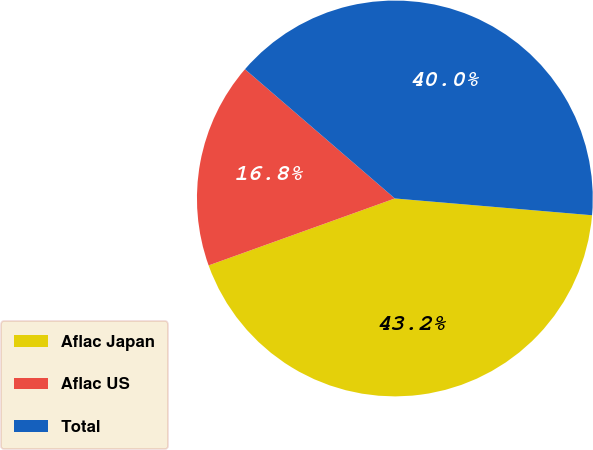Convert chart to OTSL. <chart><loc_0><loc_0><loc_500><loc_500><pie_chart><fcel>Aflac Japan<fcel>Aflac US<fcel>Total<nl><fcel>43.16%<fcel>16.82%<fcel>40.03%<nl></chart> 